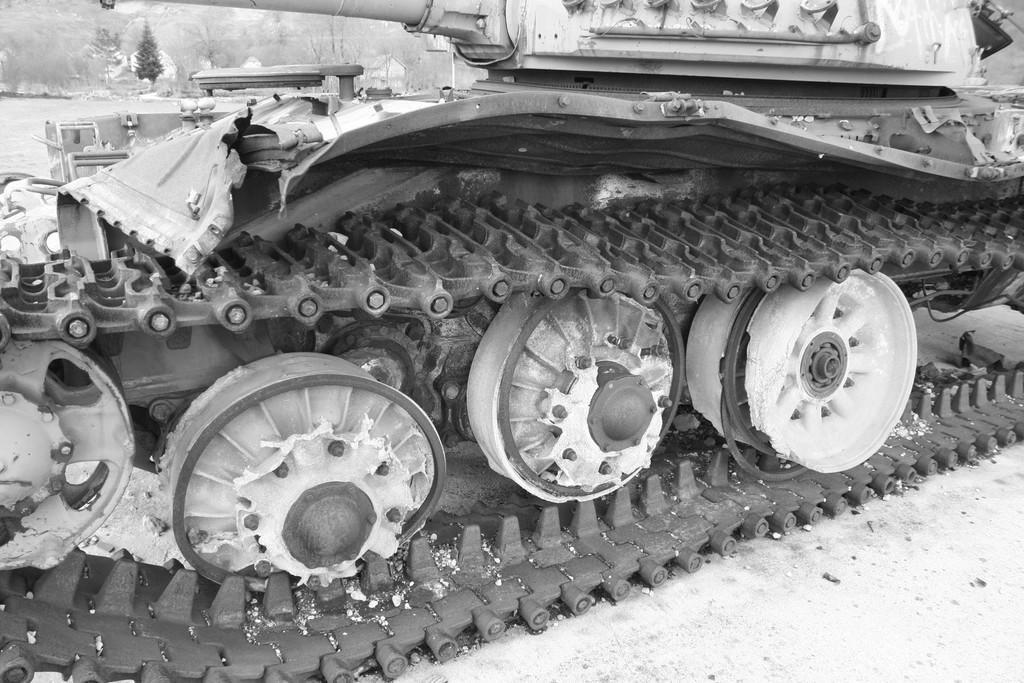Describe this image in one or two sentences. In this image we can see a vehicle which is used in desserts. 